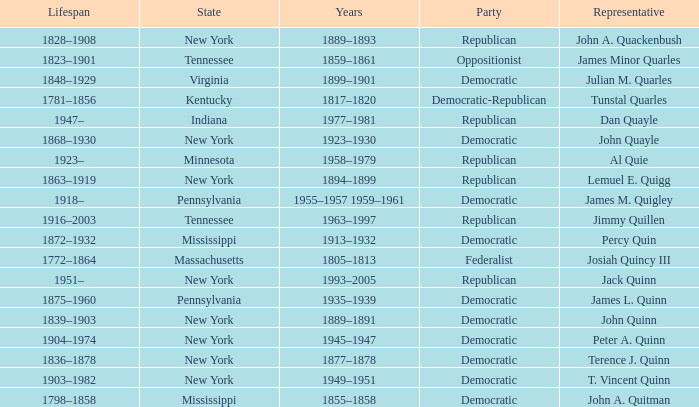Which state does Jimmy Quillen represent? Tennessee. Can you give me this table as a dict? {'header': ['Lifespan', 'State', 'Years', 'Party', 'Representative'], 'rows': [['1828–1908', 'New York', '1889–1893', 'Republican', 'John A. Quackenbush'], ['1823–1901', 'Tennessee', '1859–1861', 'Oppositionist', 'James Minor Quarles'], ['1848–1929', 'Virginia', '1899–1901', 'Democratic', 'Julian M. Quarles'], ['1781–1856', 'Kentucky', '1817–1820', 'Democratic-Republican', 'Tunstal Quarles'], ['1947–', 'Indiana', '1977–1981', 'Republican', 'Dan Quayle'], ['1868–1930', 'New York', '1923–1930', 'Democratic', 'John Quayle'], ['1923–', 'Minnesota', '1958–1979', 'Republican', 'Al Quie'], ['1863–1919', 'New York', '1894–1899', 'Republican', 'Lemuel E. Quigg'], ['1918–', 'Pennsylvania', '1955–1957 1959–1961', 'Democratic', 'James M. Quigley'], ['1916–2003', 'Tennessee', '1963–1997', 'Republican', 'Jimmy Quillen'], ['1872–1932', 'Mississippi', '1913–1932', 'Democratic', 'Percy Quin'], ['1772–1864', 'Massachusetts', '1805–1813', 'Federalist', 'Josiah Quincy III'], ['1951–', 'New York', '1993–2005', 'Republican', 'Jack Quinn'], ['1875–1960', 'Pennsylvania', '1935–1939', 'Democratic', 'James L. Quinn'], ['1839–1903', 'New York', '1889–1891', 'Democratic', 'John Quinn'], ['1904–1974', 'New York', '1945–1947', 'Democratic', 'Peter A. Quinn'], ['1836–1878', 'New York', '1877–1878', 'Democratic', 'Terence J. Quinn'], ['1903–1982', 'New York', '1949–1951', 'Democratic', 'T. Vincent Quinn'], ['1798–1858', 'Mississippi', '1855–1858', 'Democratic', 'John A. Quitman']]} 